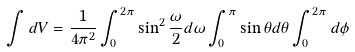Convert formula to latex. <formula><loc_0><loc_0><loc_500><loc_500>\int d V = \frac { 1 } { 4 \pi ^ { 2 } } \int _ { 0 } ^ { 2 \pi } \sin ^ { 2 } \frac { \omega } { 2 } d \omega \int _ { 0 } ^ { \pi } \sin \theta d \theta \int _ { 0 } ^ { 2 \pi } d \phi \</formula> 